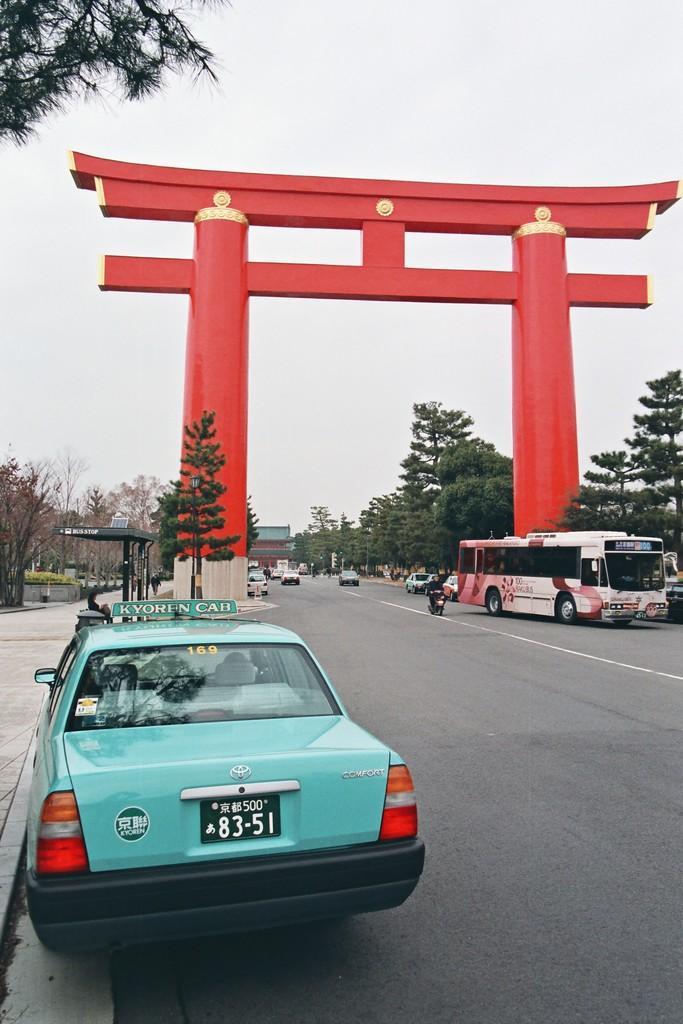How would you summarize this image in a sentence or two? In this picture I can observe blue color car on the left side of the road. On the right side of the picture I can observe a bus. In the middle of the picture I can observe red color arch. In the background there are some trees and sky. 